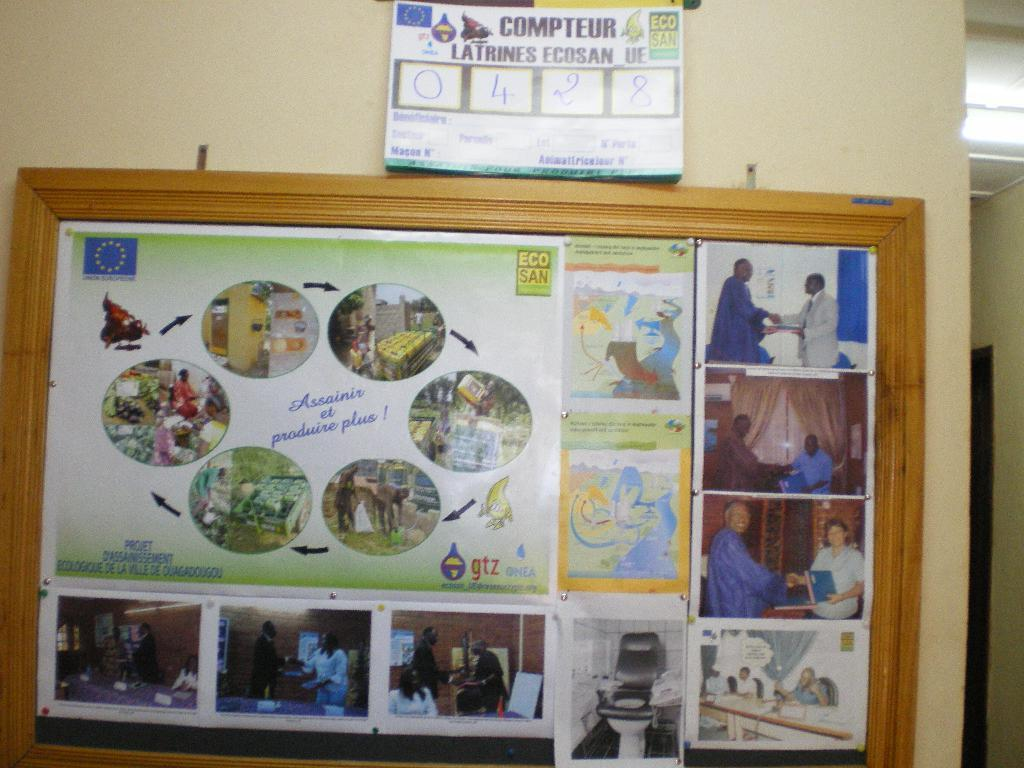<image>
Create a compact narrative representing the image presented. Bulletin board that shows people shaking hands and the words "Assainir et Produire plus!" on top. 